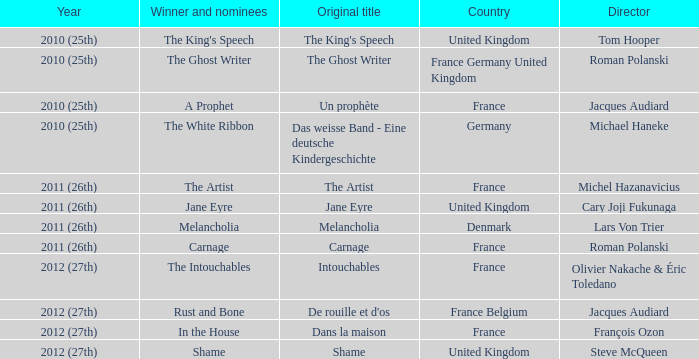Who was the director of the king's speech? Tom Hooper. 